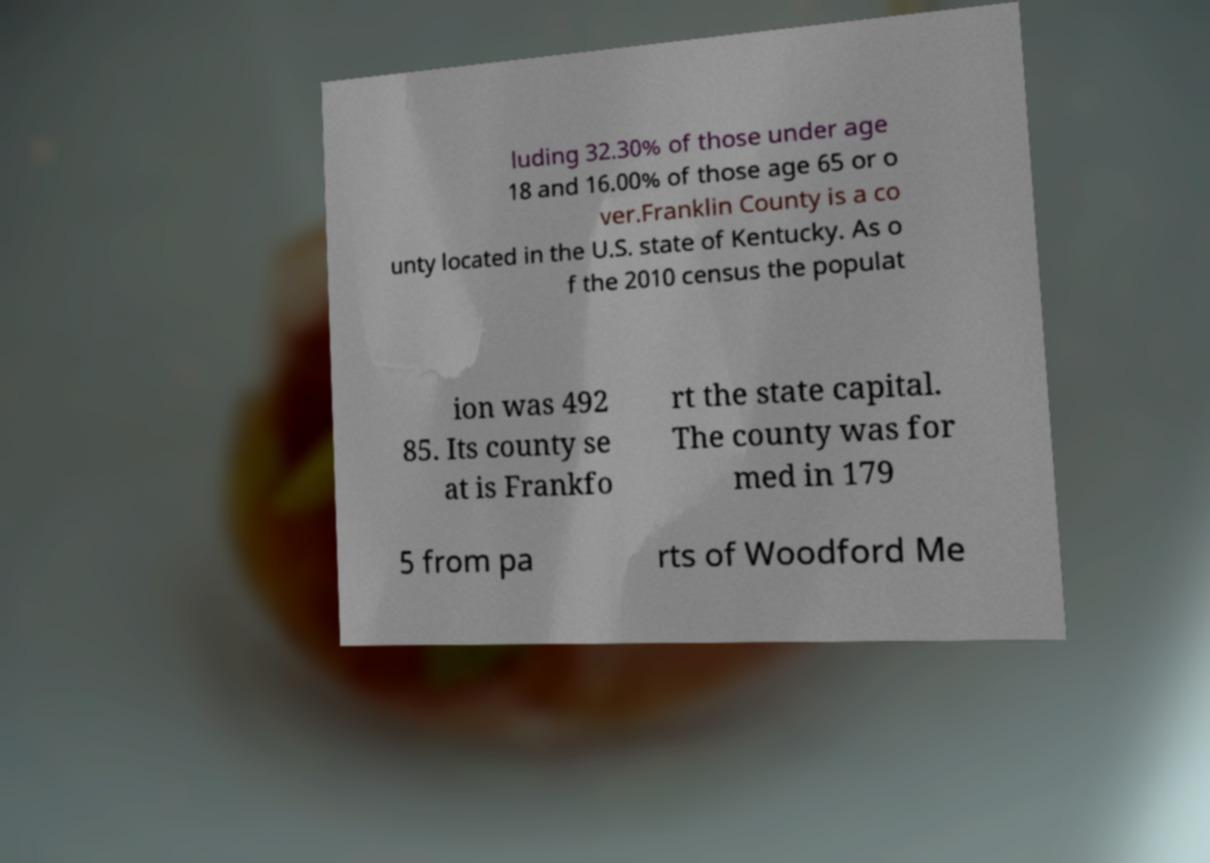Please read and relay the text visible in this image. What does it say? luding 32.30% of those under age 18 and 16.00% of those age 65 or o ver.Franklin County is a co unty located in the U.S. state of Kentucky. As o f the 2010 census the populat ion was 492 85. Its county se at is Frankfo rt the state capital. The county was for med in 179 5 from pa rts of Woodford Me 